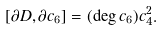<formula> <loc_0><loc_0><loc_500><loc_500>[ \partial D , \partial c _ { 6 } ] = ( \deg c _ { 6 } ) c _ { 4 } ^ { 2 } .</formula> 